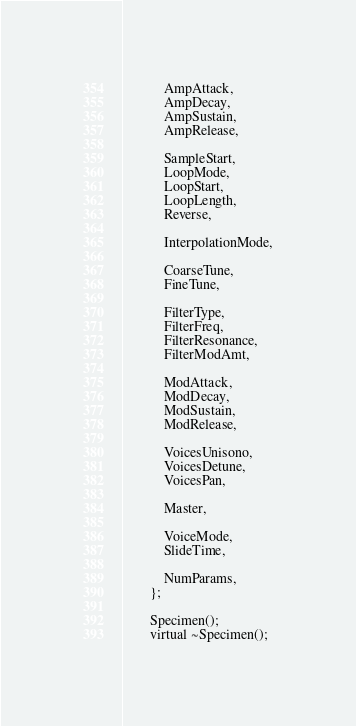Convert code to text. <code><loc_0><loc_0><loc_500><loc_500><_C_>			AmpAttack,
			AmpDecay,
			AmpSustain,
			AmpRelease,

			SampleStart,
			LoopMode,
			LoopStart,
			LoopLength,
			Reverse,

			InterpolationMode,

			CoarseTune,
			FineTune,

			FilterType,
			FilterFreq,
			FilterResonance,
			FilterModAmt,

			ModAttack,
			ModDecay,
			ModSustain,
			ModRelease,

			VoicesUnisono,
			VoicesDetune,
			VoicesPan,

			Master,

			VoiceMode,
			SlideTime,

			NumParams,
		};

		Specimen();
		virtual ~Specimen();
</code> 